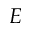<formula> <loc_0><loc_0><loc_500><loc_500>E</formula> 